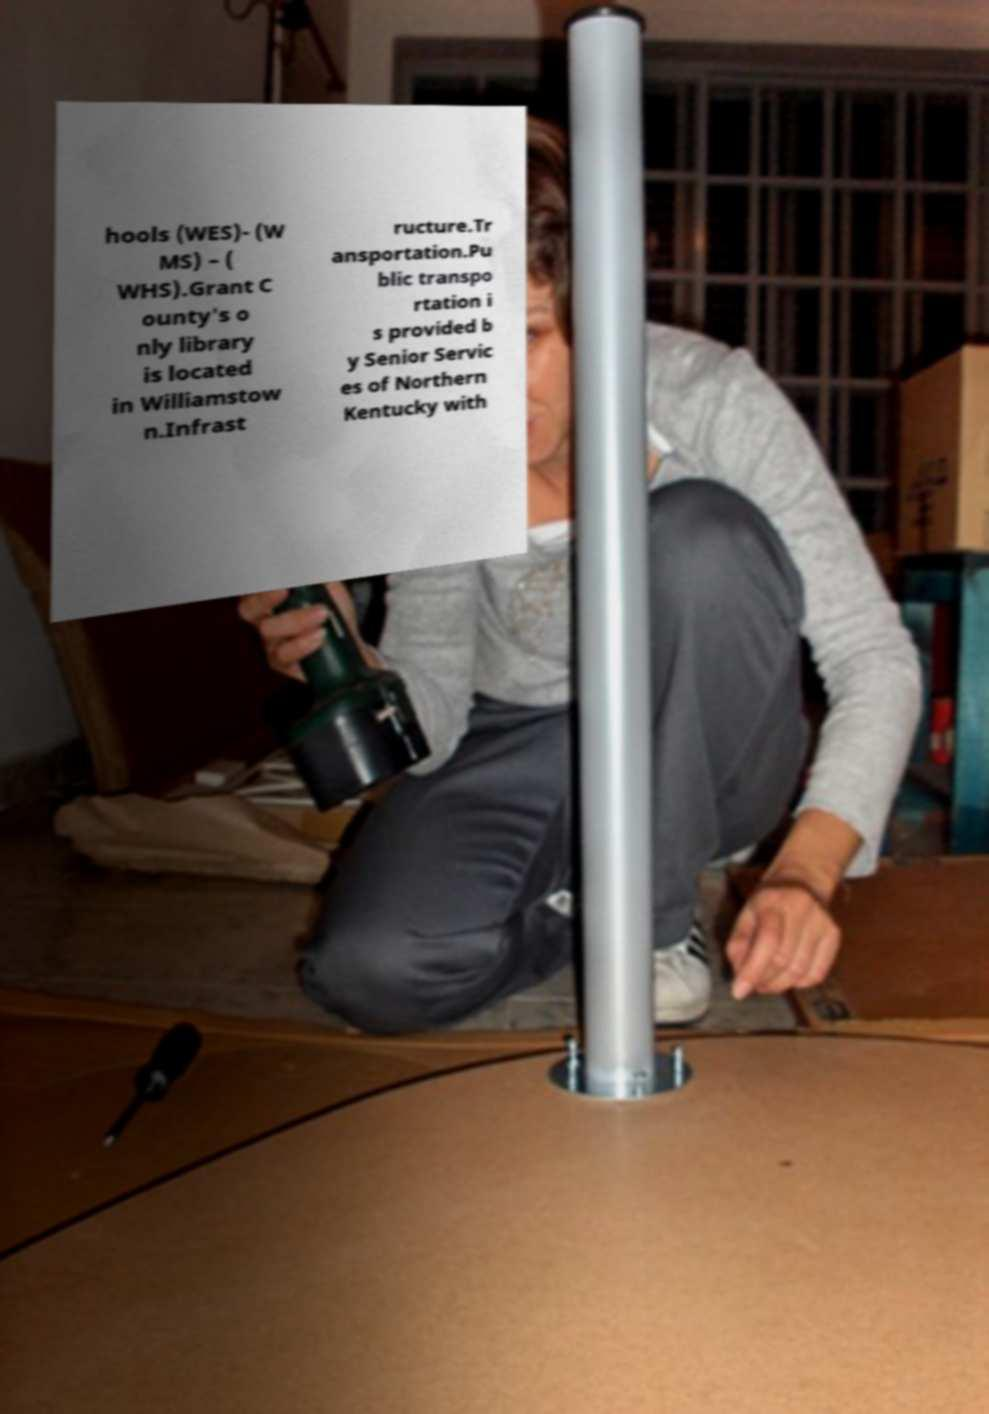Please read and relay the text visible in this image. What does it say? hools (WES)- (W MS) – ( WHS).Grant C ounty's o nly library is located in Williamstow n.Infrast ructure.Tr ansportation.Pu blic transpo rtation i s provided b y Senior Servic es of Northern Kentucky with 